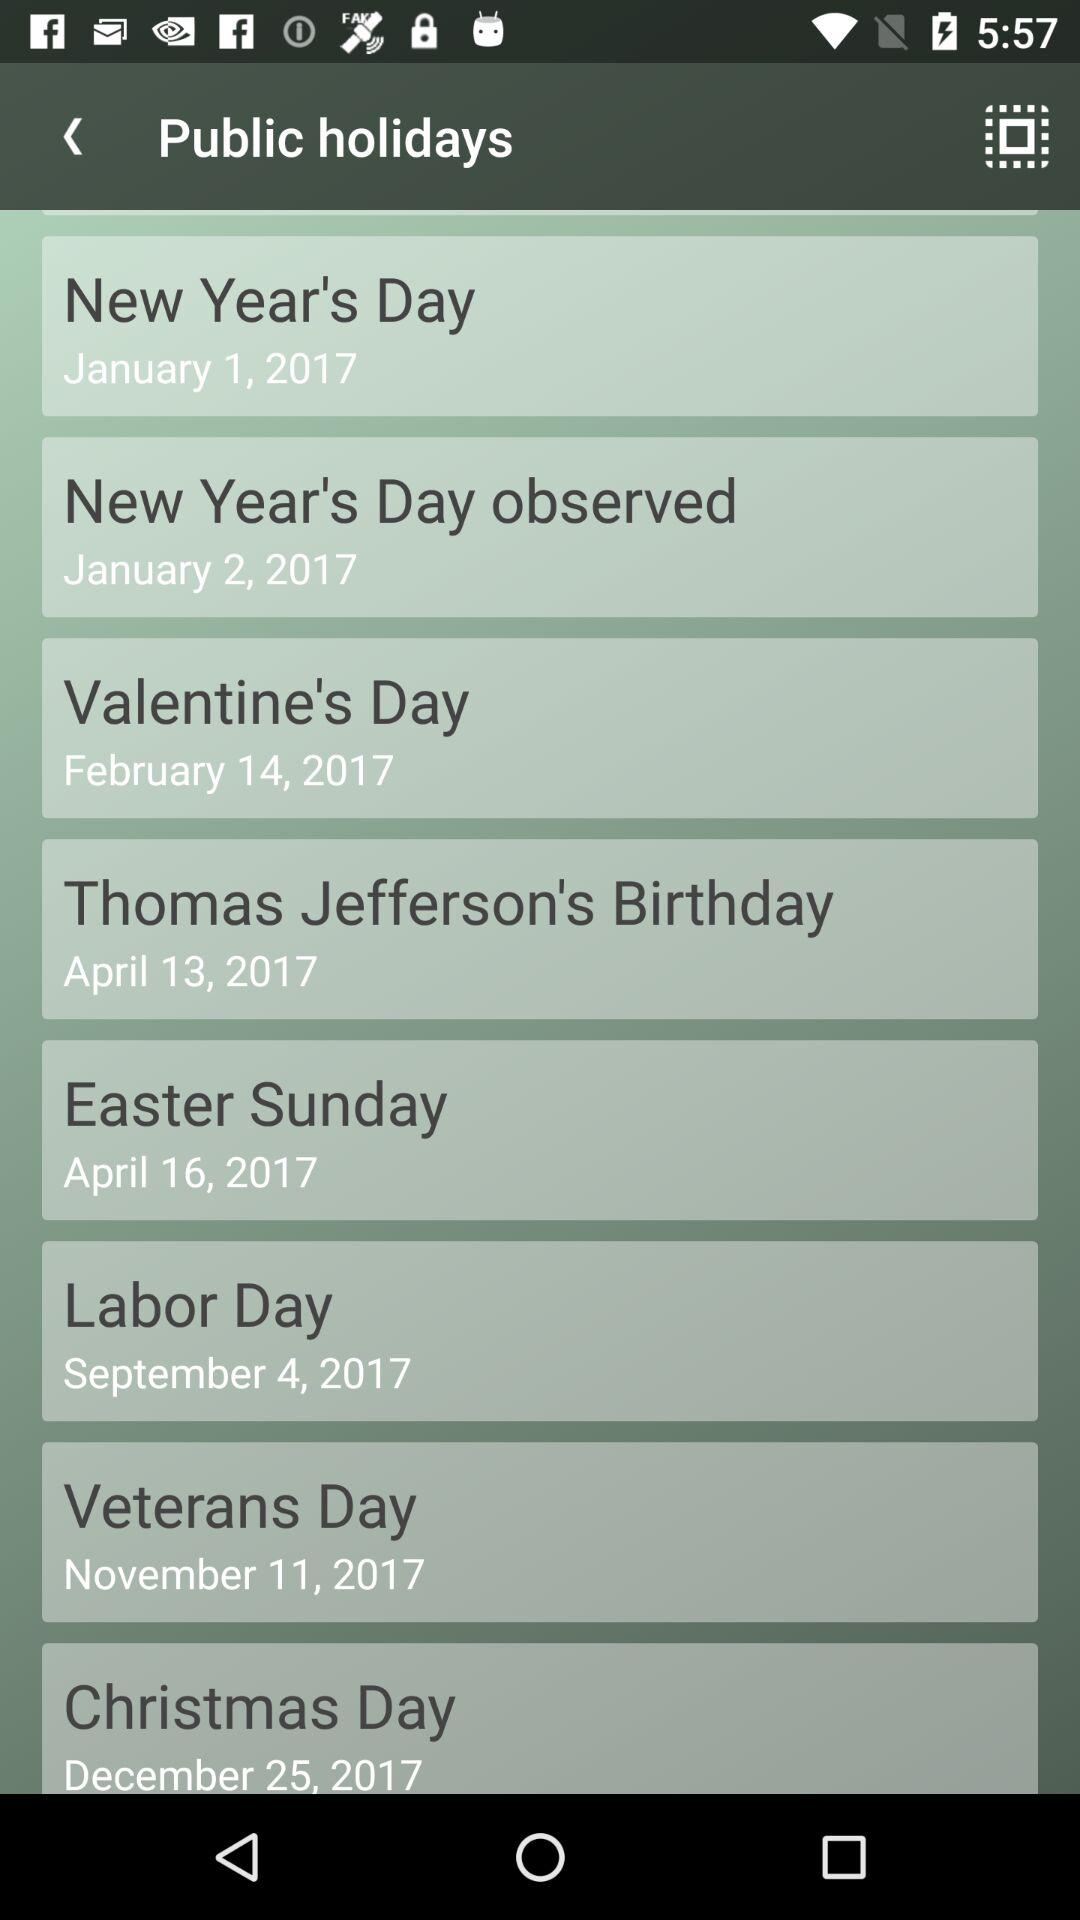When is the holiday for Labor Day? The holiday for Labor Day is on September 4, 2017. 